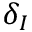Convert formula to latex. <formula><loc_0><loc_0><loc_500><loc_500>\delta _ { I }</formula> 